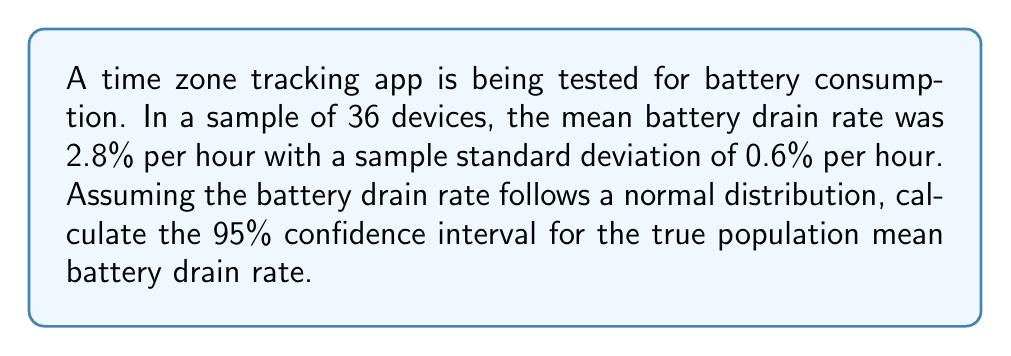Solve this math problem. To calculate the confidence interval, we'll follow these steps:

1) The formula for the confidence interval is:

   $$ \bar{x} \pm t_{\alpha/2, n-1} \cdot \frac{s}{\sqrt{n}} $$

   Where:
   - $\bar{x}$ is the sample mean
   - $t_{\alpha/2, n-1}$ is the t-value for a 95% confidence level with n-1 degrees of freedom
   - $s$ is the sample standard deviation
   - $n$ is the sample size

2) We know:
   - $\bar{x} = 2.8\%$ per hour
   - $s = 0.6\%$ per hour
   - $n = 36$
   - For a 95% confidence level, $\alpha = 0.05$

3) Degrees of freedom = $n - 1 = 36 - 1 = 35$

4) From the t-distribution table, $t_{0.025, 35} \approx 2.030$

5) Calculate the margin of error:

   $$ \text{Margin of Error} = t_{\alpha/2, n-1} \cdot \frac{s}{\sqrt{n}} = 2.030 \cdot \frac{0.6}{\sqrt{36}} \approx 0.203 $$

6) Calculate the confidence interval:

   $$ 2.8 \pm 0.203 $$

   Lower bound: $2.8 - 0.203 = 2.597\%$ per hour
   Upper bound: $2.8 + 0.203 = 3.003\%$ per hour
Answer: (2.597%, 3.003%) per hour 